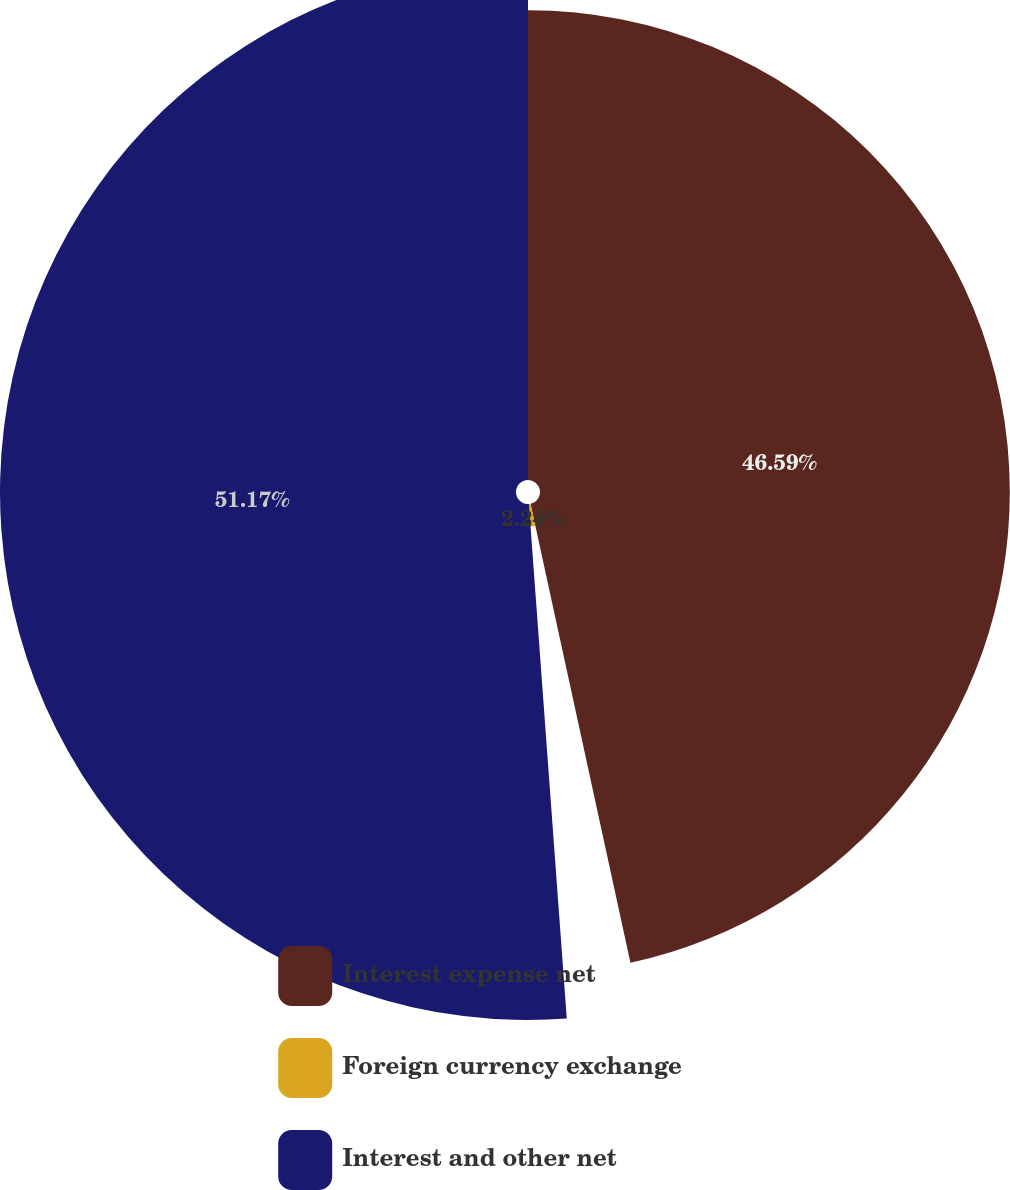Convert chart. <chart><loc_0><loc_0><loc_500><loc_500><pie_chart><fcel>Interest expense net<fcel>Foreign currency exchange<fcel>Interest and other net<nl><fcel>46.59%<fcel>2.24%<fcel>51.17%<nl></chart> 